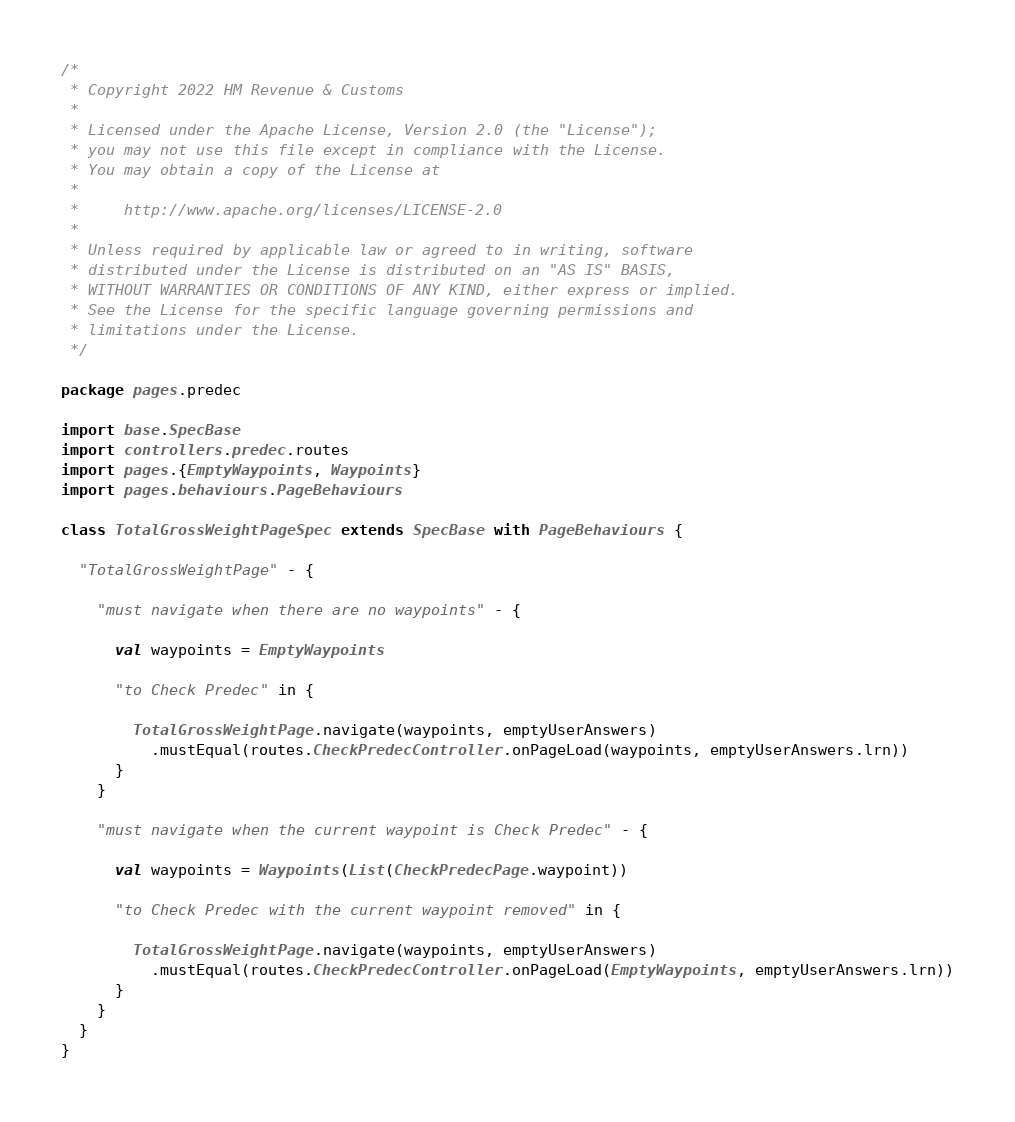Convert code to text. <code><loc_0><loc_0><loc_500><loc_500><_Scala_>/*
 * Copyright 2022 HM Revenue & Customs
 *
 * Licensed under the Apache License, Version 2.0 (the "License");
 * you may not use this file except in compliance with the License.
 * You may obtain a copy of the License at
 *
 *     http://www.apache.org/licenses/LICENSE-2.0
 *
 * Unless required by applicable law or agreed to in writing, software
 * distributed under the License is distributed on an "AS IS" BASIS,
 * WITHOUT WARRANTIES OR CONDITIONS OF ANY KIND, either express or implied.
 * See the License for the specific language governing permissions and
 * limitations under the License.
 */

package pages.predec

import base.SpecBase
import controllers.predec.routes
import pages.{EmptyWaypoints, Waypoints}
import pages.behaviours.PageBehaviours

class TotalGrossWeightPageSpec extends SpecBase with PageBehaviours {

  "TotalGrossWeightPage" - {

    "must navigate when there are no waypoints" - {

      val waypoints = EmptyWaypoints

      "to Check Predec" in {

        TotalGrossWeightPage.navigate(waypoints, emptyUserAnswers)
          .mustEqual(routes.CheckPredecController.onPageLoad(waypoints, emptyUserAnswers.lrn))
      }
    }

    "must navigate when the current waypoint is Check Predec" - {

      val waypoints = Waypoints(List(CheckPredecPage.waypoint))

      "to Check Predec with the current waypoint removed" in {

        TotalGrossWeightPage.navigate(waypoints, emptyUserAnswers)
          .mustEqual(routes.CheckPredecController.onPageLoad(EmptyWaypoints, emptyUserAnswers.lrn))
      }
    }
  }
}
</code> 